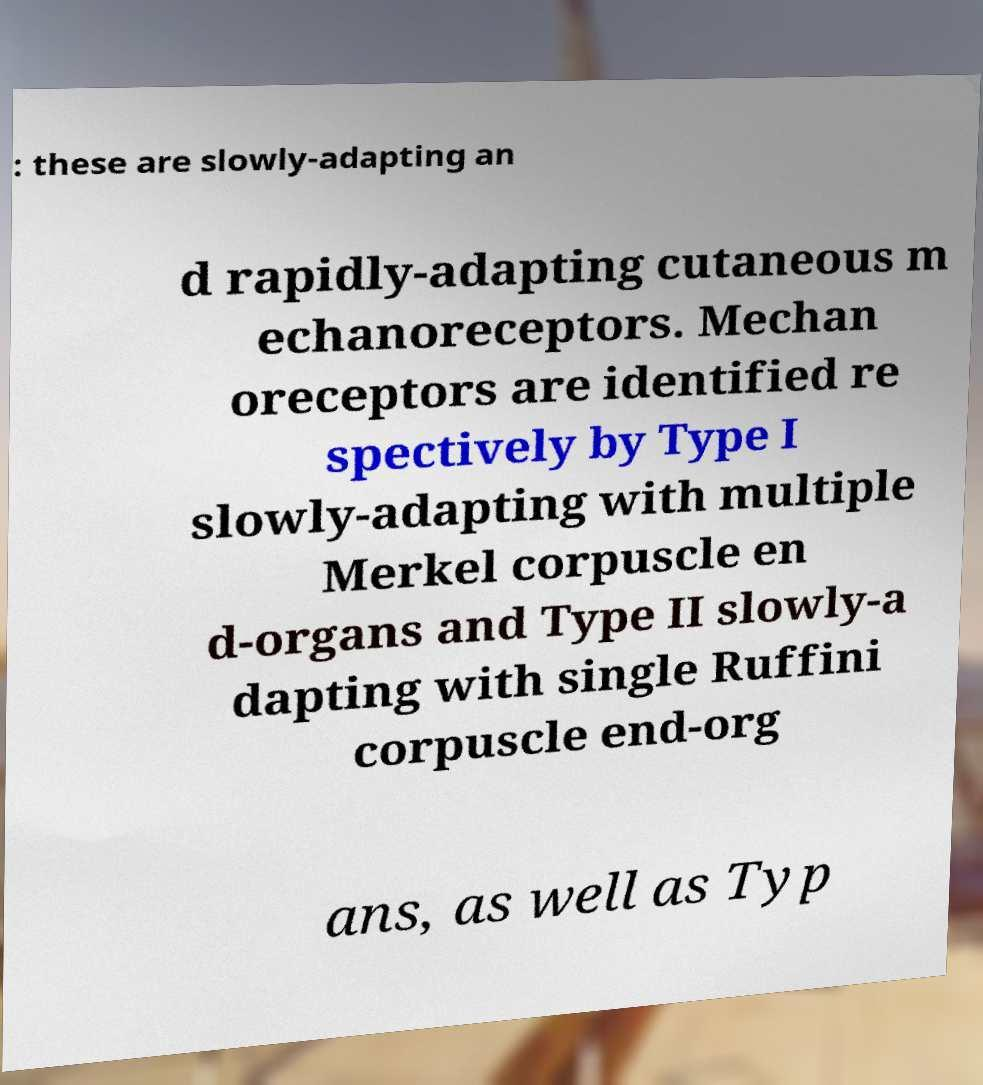Please identify and transcribe the text found in this image. : these are slowly-adapting an d rapidly-adapting cutaneous m echanoreceptors. Mechan oreceptors are identified re spectively by Type I slowly-adapting with multiple Merkel corpuscle en d-organs and Type II slowly-a dapting with single Ruffini corpuscle end-org ans, as well as Typ 